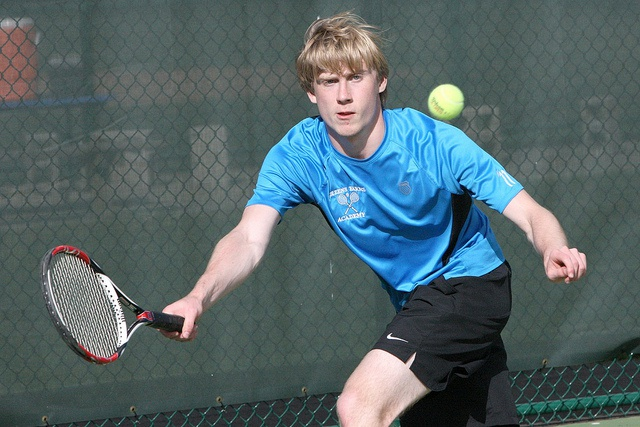Describe the objects in this image and their specific colors. I can see people in purple, black, pink, and lightblue tones, tennis racket in purple, gray, lightgray, darkgray, and black tones, and sports ball in purple, khaki, lightyellow, lightgreen, and green tones in this image. 